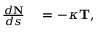<formula> <loc_0><loc_0><loc_500><loc_500>\begin{array} { r l } { { \frac { d N } { d s } } } & = - \kappa T , } \end{array}</formula> 